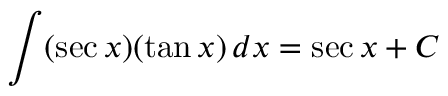Convert formula to latex. <formula><loc_0><loc_0><loc_500><loc_500>\int ( \sec x ) ( \tan x ) \, d x = \sec x + C</formula> 